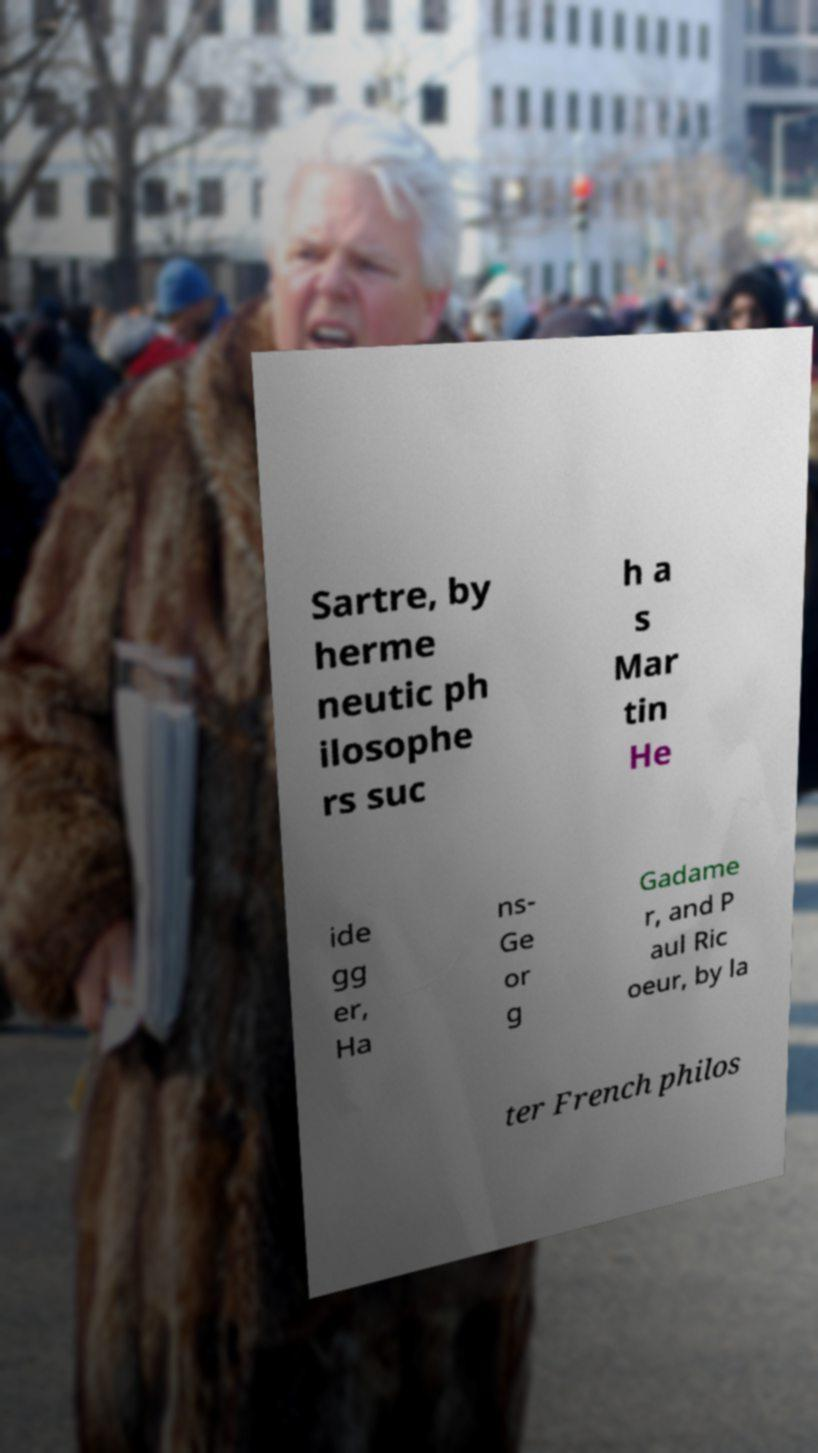For documentation purposes, I need the text within this image transcribed. Could you provide that? Sartre, by herme neutic ph ilosophe rs suc h a s Mar tin He ide gg er, Ha ns- Ge or g Gadame r, and P aul Ric oeur, by la ter French philos 